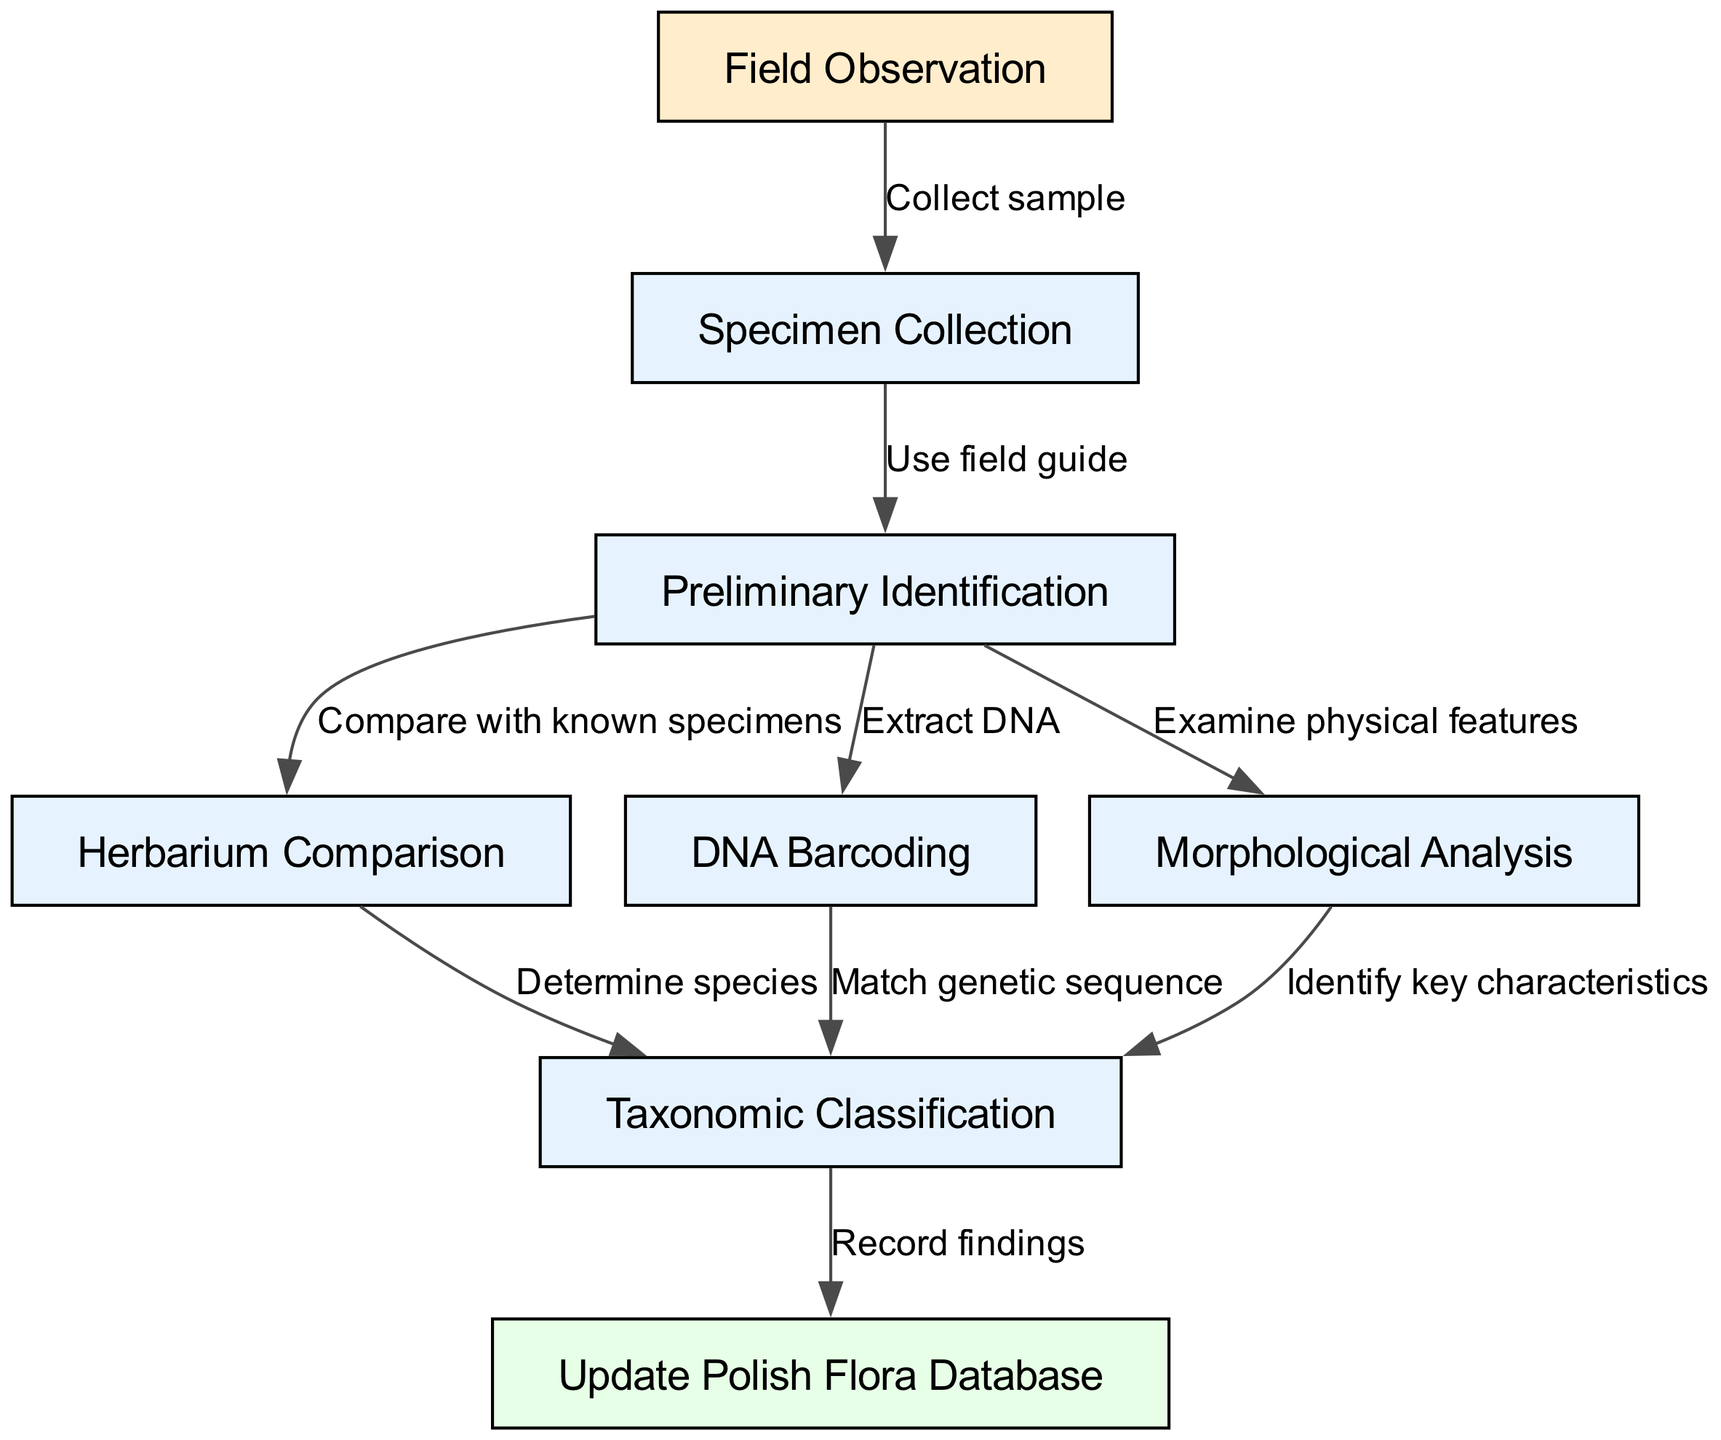What is the first step in the plant identification process? The first node in the flowchart is "Field Observation," which is indicated as the starting point of the process.
Answer: Field Observation How many nodes are there in the diagram? By counting all the distinct nodes listed (1 through 8), we find there are a total of 8 nodes.
Answer: 8 Which process follows "Specimen Collection"? The diagram shows that after "Specimen Collection," the next step is "Preliminary Identification," connected by the edge labeled "Use field guide."
Answer: Preliminary Identification What type of analysis follows "Preliminary Identification"? The flowchart indicates three analyses that can follow "Preliminary Identification": "Herbarium Comparison," "DNA Barcoding," and "Morphological Analysis."
Answer: Herbarium Comparison, DNA Barcoding, Morphological Analysis What determines the species after "Herbarium Comparison"? According to the flowchart, "Herbarium Comparison" leads directly to "Taxonomic Classification," indicating this step helps determine the species.
Answer: Taxonomic Classification What is the final step in the plant identification process? The final node in the flowchart is "Update Polish Flora Database," which comes after "Taxonomic Classification."
Answer: Update Polish Flora Database Which process involves matching a genetic sequence? The step that involves matching a genetic sequence is "DNA Barcoding," which connects to "Taxonomic Classification," indicating this analysis leads to species identification.
Answer: DNA Barcoding How many edges connect to "Taxonomic Classification"? The flowchart shows that "Taxonomic Classification" has three incoming edges from "Herbarium Comparison," "DNA Barcoding," and "Morphological Analysis."
Answer: 3 What does the final step involve? The final step, "Update Polish Flora Database," involves recording the findings from the previous steps, indicating documentation of the identification process.
Answer: Record findings 